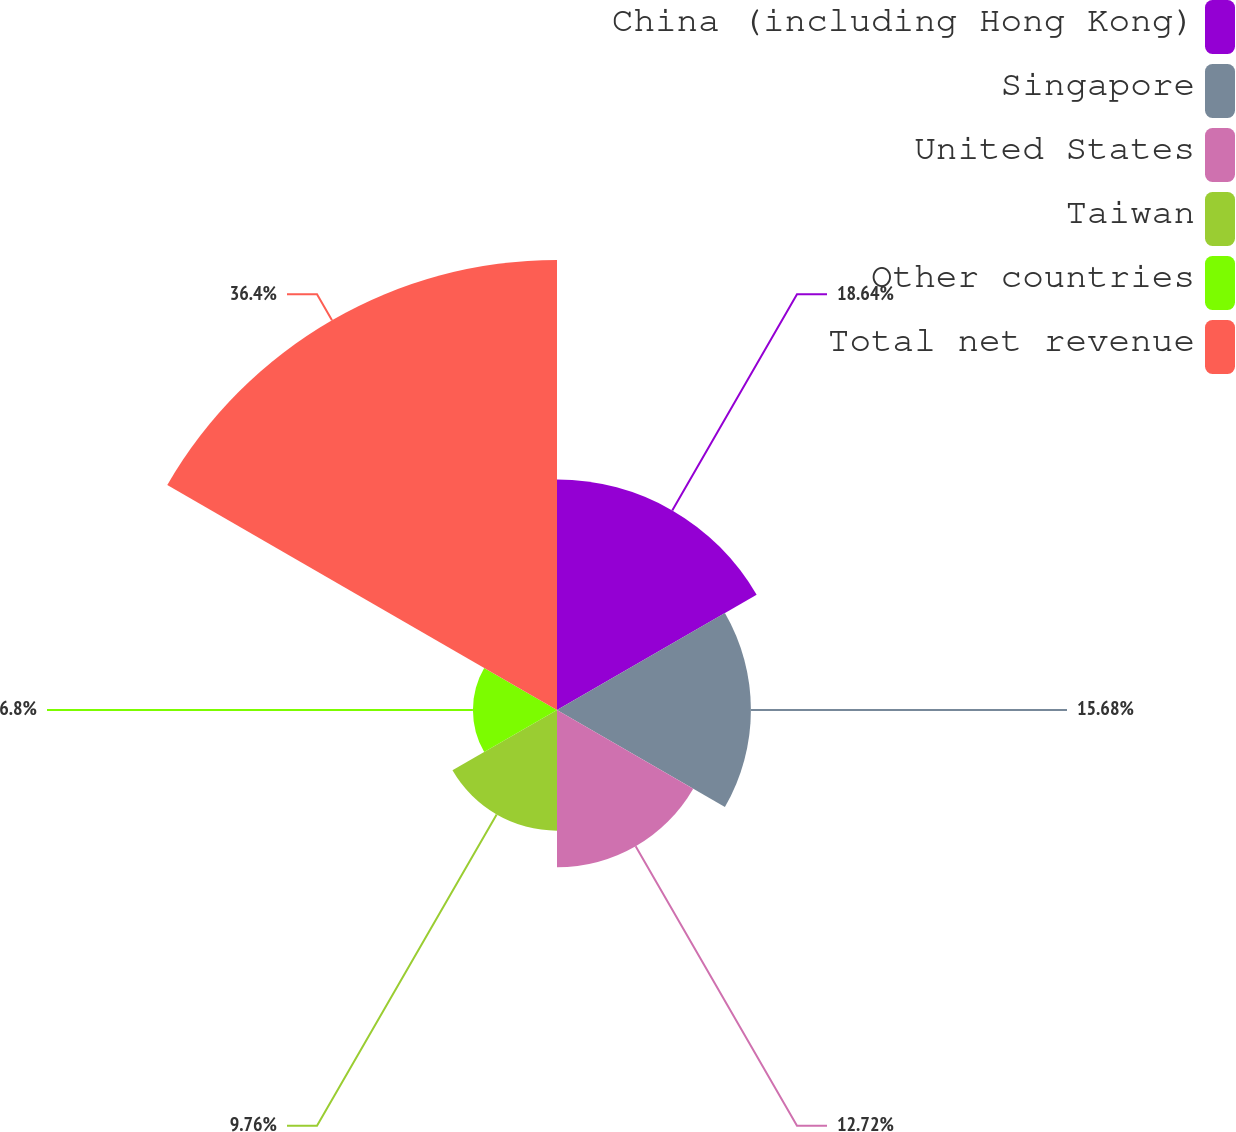Convert chart. <chart><loc_0><loc_0><loc_500><loc_500><pie_chart><fcel>China (including Hong Kong)<fcel>Singapore<fcel>United States<fcel>Taiwan<fcel>Other countries<fcel>Total net revenue<nl><fcel>18.64%<fcel>15.68%<fcel>12.72%<fcel>9.76%<fcel>6.8%<fcel>36.39%<nl></chart> 